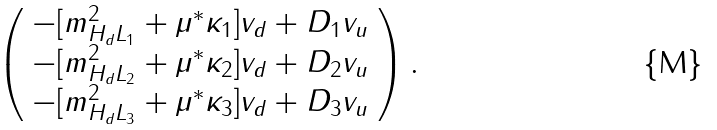Convert formula to latex. <formula><loc_0><loc_0><loc_500><loc_500>\left ( \begin{array} { l } - [ { m } _ { H _ { d } L _ { 1 } } ^ { 2 } + \mu ^ { * } \kappa _ { 1 } ] v _ { d } + D _ { 1 } v _ { u } \\ - [ { m } _ { H _ { d } L _ { 2 } } ^ { 2 } + \mu ^ { * } \kappa _ { 2 } ] v _ { d } + D _ { 2 } v _ { u } \\ - [ { m } _ { H _ { d } L _ { 3 } } ^ { 2 } + \mu ^ { * } \kappa _ { 3 } ] v _ { d } + D _ { 3 } v _ { u } \end{array} \right ) .</formula> 